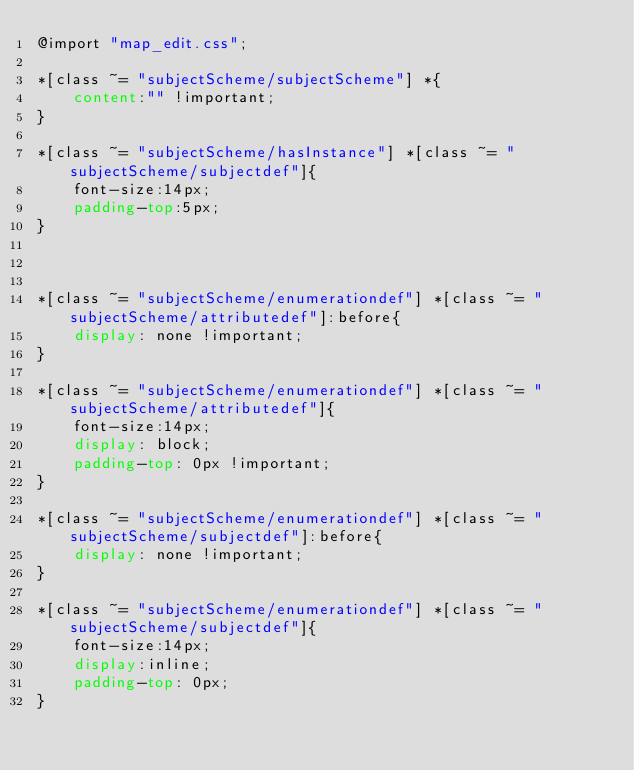<code> <loc_0><loc_0><loc_500><loc_500><_CSS_>@import "map_edit.css";

*[class ~= "subjectScheme/subjectScheme"] *{
    content:"" !important;
}

*[class ~= "subjectScheme/hasInstance"] *[class ~= "subjectScheme/subjectdef"]{
    font-size:14px;
    padding-top:5px;
}



*[class ~= "subjectScheme/enumerationdef"] *[class ~= "subjectScheme/attributedef"]:before{
    display: none !important;
}

*[class ~= "subjectScheme/enumerationdef"] *[class ~= "subjectScheme/attributedef"]{
    font-size:14px;
    display: block;
    padding-top: 0px !important;
}

*[class ~= "subjectScheme/enumerationdef"] *[class ~= "subjectScheme/subjectdef"]:before{
    display: none !important;
}

*[class ~= "subjectScheme/enumerationdef"] *[class ~= "subjectScheme/subjectdef"]{
    font-size:14px;
    display:inline;
    padding-top: 0px;
}</code> 